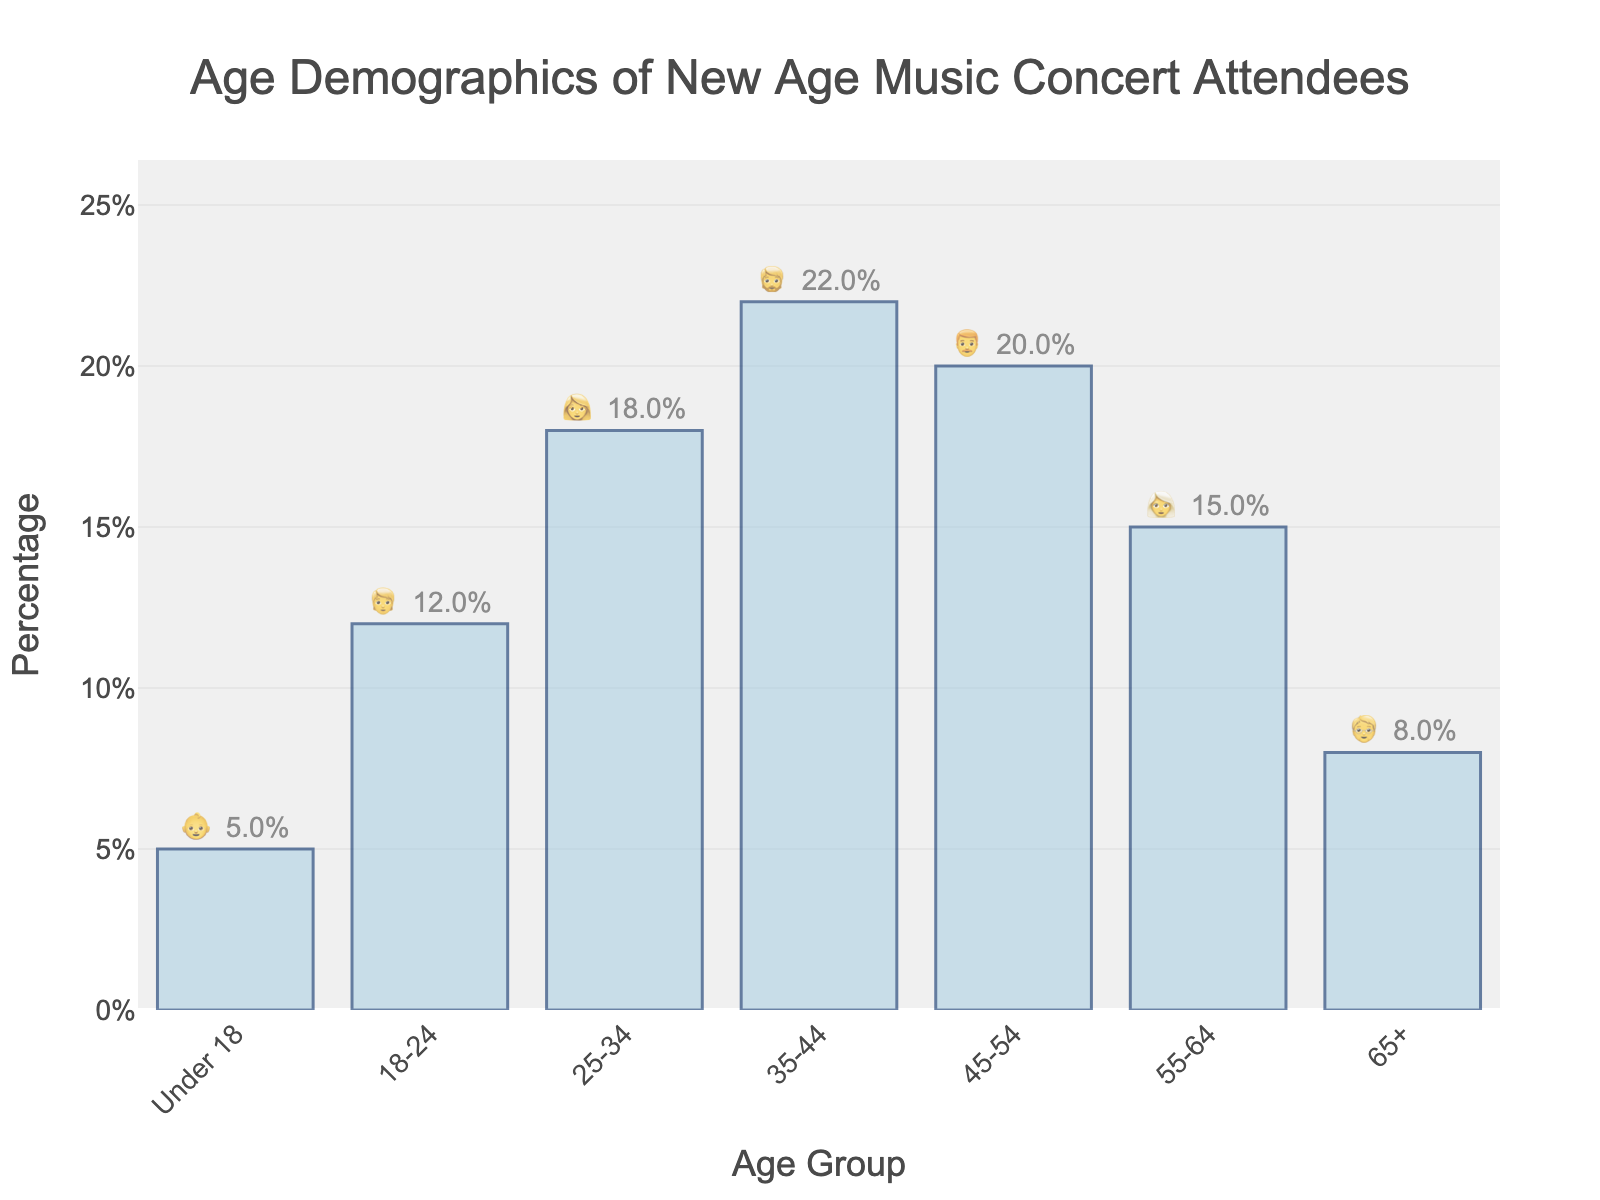What's the title of the chart? The title is usually placed at the top of the chart, summarizing its content.
Answer: Age Demographics of New Age Music Concert Attendees Which age group has the highest percentage of attendees? First, identify the age group with the tallest bar in the figure, then check the associated percentage.
Answer: 35-44 What is the percentage of attendees aged 25-34? Locate the bar labeled "25-34" and read the percentage value displayed on or above it.
Answer: 18% How does the percentage of attendees aged 45-54 compare to those aged 65+? Locate and compare the heights of the bars labeled "45-54" and "65+". The bar representing the 45-54 age group is taller.
Answer: The 45-54 group is higher What is the combined percentage of attendees aged under 18 and aged 18-24? Locate the percentages for "Under 18" (5%) and "18-24" (12%), then add them together: 5% + 12% = 17%.
Answer: 17% Which age groups have a percentage of attendees greater than 15%? Identify bars with percentages above the 15% mark: "25-34", "35-44", "45-54".
Answer: 25-34, 35-44, 45-54 How much larger is the percentage of attendees aged 55-64 compared to those aged under 18? Subtract the percentage of the "Under 18" group (5%) from the "55-64" group (15%): 15% - 5% = 10%.
Answer: 10% Arrange the age groups in descending order of their percentage of attendees. List the groups from highest to lowest by comparing the heights of their respective bars: "35-44" > "45-54" > "25-34" > "55-64" > "65+" > "18-24" > "Under 18".
Answer: 35-44, 45-54, 25-34, 55-64, 65+, 18-24, Under 18 What percentage of the total attendees are aged 35 and older? Sum the percentages for age groups "35-44" (22%), "45-54" (20%), "55-64" (15%), and "65+" (8%): 22% + 20% + 15% + 8% = 65%.
Answer: 65% Which age group has the lowest percentage of attendees, and what is that percentage? Locate the smallest bar and read its percentage value, which is for "Under 18".
Answer: Under 18, 5% 